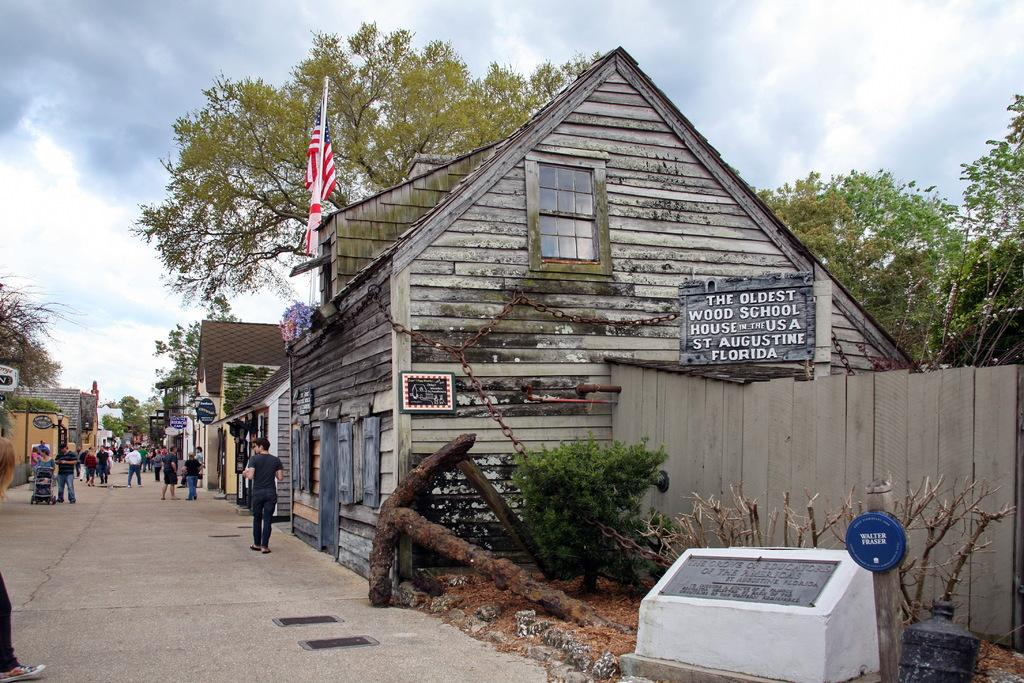What type of structures can be seen in the image? There are buildings in the image. Can you describe the people in the image? There is a group of people in the image. What else is present in the image besides buildings and people? There are boards, trees, and other objects in the image. What can be seen in the background of the image? The sky is visible in the background of the image. What type of bells are hanging from the trees in the image? There are no bells present in the image; it features buildings, a group of people, boards, trees, and other objects, but no bells. How many elbows can be seen in the image? It is impossible to count elbows in the image, as it is not a body part that can be easily identified or counted in this context. 